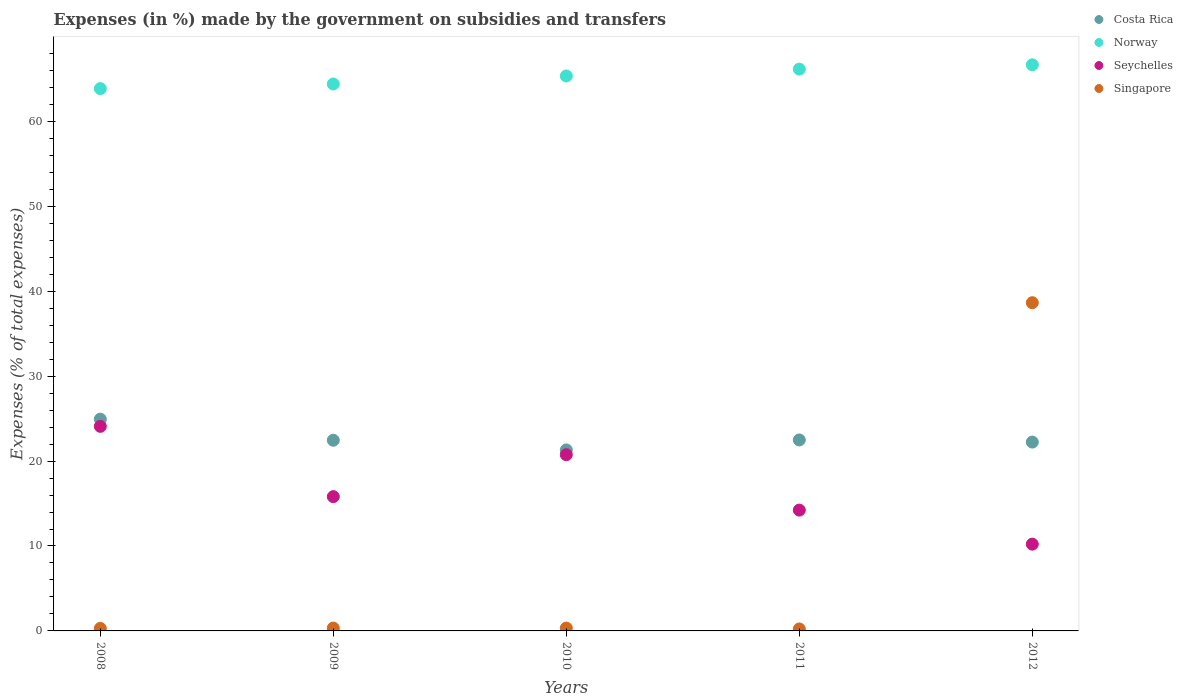Is the number of dotlines equal to the number of legend labels?
Offer a very short reply. Yes. What is the percentage of expenses made by the government on subsidies and transfers in Norway in 2010?
Your answer should be compact. 65.35. Across all years, what is the maximum percentage of expenses made by the government on subsidies and transfers in Singapore?
Provide a short and direct response. 38.65. Across all years, what is the minimum percentage of expenses made by the government on subsidies and transfers in Costa Rica?
Ensure brevity in your answer.  21.31. In which year was the percentage of expenses made by the government on subsidies and transfers in Singapore maximum?
Ensure brevity in your answer.  2012. What is the total percentage of expenses made by the government on subsidies and transfers in Costa Rica in the graph?
Offer a very short reply. 113.43. What is the difference between the percentage of expenses made by the government on subsidies and transfers in Seychelles in 2008 and that in 2010?
Provide a succinct answer. 3.34. What is the difference between the percentage of expenses made by the government on subsidies and transfers in Norway in 2011 and the percentage of expenses made by the government on subsidies and transfers in Costa Rica in 2008?
Provide a succinct answer. 41.22. What is the average percentage of expenses made by the government on subsidies and transfers in Seychelles per year?
Your answer should be very brief. 17.02. In the year 2008, what is the difference between the percentage of expenses made by the government on subsidies and transfers in Norway and percentage of expenses made by the government on subsidies and transfers in Singapore?
Make the answer very short. 63.56. In how many years, is the percentage of expenses made by the government on subsidies and transfers in Seychelles greater than 24 %?
Give a very brief answer. 1. What is the ratio of the percentage of expenses made by the government on subsidies and transfers in Seychelles in 2010 to that in 2012?
Give a very brief answer. 2.03. What is the difference between the highest and the second highest percentage of expenses made by the government on subsidies and transfers in Costa Rica?
Your response must be concise. 2.45. What is the difference between the highest and the lowest percentage of expenses made by the government on subsidies and transfers in Costa Rica?
Offer a terse response. 3.62. In how many years, is the percentage of expenses made by the government on subsidies and transfers in Norway greater than the average percentage of expenses made by the government on subsidies and transfers in Norway taken over all years?
Provide a succinct answer. 3. Is the sum of the percentage of expenses made by the government on subsidies and transfers in Norway in 2008 and 2011 greater than the maximum percentage of expenses made by the government on subsidies and transfers in Seychelles across all years?
Provide a succinct answer. Yes. Is it the case that in every year, the sum of the percentage of expenses made by the government on subsidies and transfers in Seychelles and percentage of expenses made by the government on subsidies and transfers in Norway  is greater than the sum of percentage of expenses made by the government on subsidies and transfers in Costa Rica and percentage of expenses made by the government on subsidies and transfers in Singapore?
Provide a succinct answer. Yes. Does the percentage of expenses made by the government on subsidies and transfers in Singapore monotonically increase over the years?
Keep it short and to the point. No. Is the percentage of expenses made by the government on subsidies and transfers in Costa Rica strictly less than the percentage of expenses made by the government on subsidies and transfers in Seychelles over the years?
Your answer should be very brief. No. How many dotlines are there?
Offer a very short reply. 4. Are the values on the major ticks of Y-axis written in scientific E-notation?
Your answer should be compact. No. Does the graph contain grids?
Give a very brief answer. No. How many legend labels are there?
Make the answer very short. 4. What is the title of the graph?
Your answer should be compact. Expenses (in %) made by the government on subsidies and transfers. Does "Russian Federation" appear as one of the legend labels in the graph?
Your answer should be compact. No. What is the label or title of the Y-axis?
Your answer should be compact. Expenses (% of total expenses). What is the Expenses (% of total expenses) in Costa Rica in 2008?
Keep it short and to the point. 24.94. What is the Expenses (% of total expenses) of Norway in 2008?
Provide a succinct answer. 63.86. What is the Expenses (% of total expenses) in Seychelles in 2008?
Offer a terse response. 24.09. What is the Expenses (% of total expenses) of Singapore in 2008?
Your answer should be compact. 0.3. What is the Expenses (% of total expenses) of Costa Rica in 2009?
Your answer should be compact. 22.45. What is the Expenses (% of total expenses) in Norway in 2009?
Ensure brevity in your answer.  64.4. What is the Expenses (% of total expenses) of Seychelles in 2009?
Your response must be concise. 15.81. What is the Expenses (% of total expenses) of Singapore in 2009?
Give a very brief answer. 0.34. What is the Expenses (% of total expenses) in Costa Rica in 2010?
Offer a terse response. 21.31. What is the Expenses (% of total expenses) in Norway in 2010?
Provide a succinct answer. 65.35. What is the Expenses (% of total expenses) in Seychelles in 2010?
Your response must be concise. 20.75. What is the Expenses (% of total expenses) in Singapore in 2010?
Your response must be concise. 0.33. What is the Expenses (% of total expenses) of Costa Rica in 2011?
Your answer should be very brief. 22.49. What is the Expenses (% of total expenses) in Norway in 2011?
Give a very brief answer. 66.15. What is the Expenses (% of total expenses) of Seychelles in 2011?
Your answer should be very brief. 14.23. What is the Expenses (% of total expenses) of Singapore in 2011?
Your answer should be very brief. 0.23. What is the Expenses (% of total expenses) in Costa Rica in 2012?
Offer a terse response. 22.24. What is the Expenses (% of total expenses) in Norway in 2012?
Ensure brevity in your answer.  66.66. What is the Expenses (% of total expenses) of Seychelles in 2012?
Give a very brief answer. 10.22. What is the Expenses (% of total expenses) in Singapore in 2012?
Give a very brief answer. 38.65. Across all years, what is the maximum Expenses (% of total expenses) in Costa Rica?
Your answer should be compact. 24.94. Across all years, what is the maximum Expenses (% of total expenses) of Norway?
Keep it short and to the point. 66.66. Across all years, what is the maximum Expenses (% of total expenses) of Seychelles?
Offer a terse response. 24.09. Across all years, what is the maximum Expenses (% of total expenses) in Singapore?
Offer a terse response. 38.65. Across all years, what is the minimum Expenses (% of total expenses) of Costa Rica?
Your answer should be very brief. 21.31. Across all years, what is the minimum Expenses (% of total expenses) in Norway?
Your answer should be very brief. 63.86. Across all years, what is the minimum Expenses (% of total expenses) in Seychelles?
Your answer should be compact. 10.22. Across all years, what is the minimum Expenses (% of total expenses) in Singapore?
Your answer should be very brief. 0.23. What is the total Expenses (% of total expenses) in Costa Rica in the graph?
Keep it short and to the point. 113.43. What is the total Expenses (% of total expenses) in Norway in the graph?
Keep it short and to the point. 326.43. What is the total Expenses (% of total expenses) of Seychelles in the graph?
Your answer should be compact. 85.1. What is the total Expenses (% of total expenses) of Singapore in the graph?
Your answer should be compact. 39.85. What is the difference between the Expenses (% of total expenses) of Costa Rica in 2008 and that in 2009?
Your response must be concise. 2.49. What is the difference between the Expenses (% of total expenses) in Norway in 2008 and that in 2009?
Ensure brevity in your answer.  -0.54. What is the difference between the Expenses (% of total expenses) of Seychelles in 2008 and that in 2009?
Offer a terse response. 8.27. What is the difference between the Expenses (% of total expenses) of Singapore in 2008 and that in 2009?
Keep it short and to the point. -0.04. What is the difference between the Expenses (% of total expenses) in Costa Rica in 2008 and that in 2010?
Provide a short and direct response. 3.62. What is the difference between the Expenses (% of total expenses) of Norway in 2008 and that in 2010?
Offer a terse response. -1.49. What is the difference between the Expenses (% of total expenses) in Seychelles in 2008 and that in 2010?
Your answer should be compact. 3.34. What is the difference between the Expenses (% of total expenses) of Singapore in 2008 and that in 2010?
Your answer should be compact. -0.03. What is the difference between the Expenses (% of total expenses) of Costa Rica in 2008 and that in 2011?
Ensure brevity in your answer.  2.45. What is the difference between the Expenses (% of total expenses) of Norway in 2008 and that in 2011?
Ensure brevity in your answer.  -2.3. What is the difference between the Expenses (% of total expenses) of Seychelles in 2008 and that in 2011?
Provide a short and direct response. 9.86. What is the difference between the Expenses (% of total expenses) of Singapore in 2008 and that in 2011?
Offer a very short reply. 0.07. What is the difference between the Expenses (% of total expenses) of Costa Rica in 2008 and that in 2012?
Your response must be concise. 2.7. What is the difference between the Expenses (% of total expenses) in Norway in 2008 and that in 2012?
Give a very brief answer. -2.81. What is the difference between the Expenses (% of total expenses) in Seychelles in 2008 and that in 2012?
Make the answer very short. 13.87. What is the difference between the Expenses (% of total expenses) in Singapore in 2008 and that in 2012?
Your answer should be compact. -38.35. What is the difference between the Expenses (% of total expenses) of Costa Rica in 2009 and that in 2010?
Give a very brief answer. 1.14. What is the difference between the Expenses (% of total expenses) of Norway in 2009 and that in 2010?
Ensure brevity in your answer.  -0.95. What is the difference between the Expenses (% of total expenses) in Seychelles in 2009 and that in 2010?
Keep it short and to the point. -4.93. What is the difference between the Expenses (% of total expenses) in Singapore in 2009 and that in 2010?
Give a very brief answer. 0. What is the difference between the Expenses (% of total expenses) in Costa Rica in 2009 and that in 2011?
Ensure brevity in your answer.  -0.04. What is the difference between the Expenses (% of total expenses) of Norway in 2009 and that in 2011?
Your answer should be compact. -1.75. What is the difference between the Expenses (% of total expenses) in Seychelles in 2009 and that in 2011?
Your response must be concise. 1.59. What is the difference between the Expenses (% of total expenses) of Singapore in 2009 and that in 2011?
Ensure brevity in your answer.  0.11. What is the difference between the Expenses (% of total expenses) of Costa Rica in 2009 and that in 2012?
Keep it short and to the point. 0.21. What is the difference between the Expenses (% of total expenses) in Norway in 2009 and that in 2012?
Give a very brief answer. -2.26. What is the difference between the Expenses (% of total expenses) of Seychelles in 2009 and that in 2012?
Provide a succinct answer. 5.6. What is the difference between the Expenses (% of total expenses) of Singapore in 2009 and that in 2012?
Provide a short and direct response. -38.31. What is the difference between the Expenses (% of total expenses) in Costa Rica in 2010 and that in 2011?
Keep it short and to the point. -1.17. What is the difference between the Expenses (% of total expenses) in Norway in 2010 and that in 2011?
Provide a short and direct response. -0.81. What is the difference between the Expenses (% of total expenses) of Seychelles in 2010 and that in 2011?
Keep it short and to the point. 6.52. What is the difference between the Expenses (% of total expenses) of Singapore in 2010 and that in 2011?
Provide a short and direct response. 0.1. What is the difference between the Expenses (% of total expenses) of Costa Rica in 2010 and that in 2012?
Your answer should be very brief. -0.92. What is the difference between the Expenses (% of total expenses) of Norway in 2010 and that in 2012?
Keep it short and to the point. -1.32. What is the difference between the Expenses (% of total expenses) in Seychelles in 2010 and that in 2012?
Ensure brevity in your answer.  10.53. What is the difference between the Expenses (% of total expenses) in Singapore in 2010 and that in 2012?
Provide a short and direct response. -38.31. What is the difference between the Expenses (% of total expenses) in Costa Rica in 2011 and that in 2012?
Provide a short and direct response. 0.25. What is the difference between the Expenses (% of total expenses) of Norway in 2011 and that in 2012?
Your response must be concise. -0.51. What is the difference between the Expenses (% of total expenses) of Seychelles in 2011 and that in 2012?
Offer a very short reply. 4.01. What is the difference between the Expenses (% of total expenses) in Singapore in 2011 and that in 2012?
Keep it short and to the point. -38.41. What is the difference between the Expenses (% of total expenses) in Costa Rica in 2008 and the Expenses (% of total expenses) in Norway in 2009?
Keep it short and to the point. -39.46. What is the difference between the Expenses (% of total expenses) in Costa Rica in 2008 and the Expenses (% of total expenses) in Seychelles in 2009?
Give a very brief answer. 9.12. What is the difference between the Expenses (% of total expenses) of Costa Rica in 2008 and the Expenses (% of total expenses) of Singapore in 2009?
Provide a short and direct response. 24.6. What is the difference between the Expenses (% of total expenses) of Norway in 2008 and the Expenses (% of total expenses) of Seychelles in 2009?
Your answer should be compact. 48.04. What is the difference between the Expenses (% of total expenses) of Norway in 2008 and the Expenses (% of total expenses) of Singapore in 2009?
Make the answer very short. 63.52. What is the difference between the Expenses (% of total expenses) in Seychelles in 2008 and the Expenses (% of total expenses) in Singapore in 2009?
Offer a terse response. 23.75. What is the difference between the Expenses (% of total expenses) of Costa Rica in 2008 and the Expenses (% of total expenses) of Norway in 2010?
Offer a terse response. -40.41. What is the difference between the Expenses (% of total expenses) of Costa Rica in 2008 and the Expenses (% of total expenses) of Seychelles in 2010?
Your answer should be compact. 4.19. What is the difference between the Expenses (% of total expenses) in Costa Rica in 2008 and the Expenses (% of total expenses) in Singapore in 2010?
Your answer should be very brief. 24.6. What is the difference between the Expenses (% of total expenses) in Norway in 2008 and the Expenses (% of total expenses) in Seychelles in 2010?
Provide a succinct answer. 43.11. What is the difference between the Expenses (% of total expenses) of Norway in 2008 and the Expenses (% of total expenses) of Singapore in 2010?
Your response must be concise. 63.52. What is the difference between the Expenses (% of total expenses) of Seychelles in 2008 and the Expenses (% of total expenses) of Singapore in 2010?
Your answer should be very brief. 23.75. What is the difference between the Expenses (% of total expenses) in Costa Rica in 2008 and the Expenses (% of total expenses) in Norway in 2011?
Give a very brief answer. -41.22. What is the difference between the Expenses (% of total expenses) of Costa Rica in 2008 and the Expenses (% of total expenses) of Seychelles in 2011?
Your answer should be compact. 10.71. What is the difference between the Expenses (% of total expenses) in Costa Rica in 2008 and the Expenses (% of total expenses) in Singapore in 2011?
Offer a very short reply. 24.7. What is the difference between the Expenses (% of total expenses) in Norway in 2008 and the Expenses (% of total expenses) in Seychelles in 2011?
Your answer should be compact. 49.63. What is the difference between the Expenses (% of total expenses) in Norway in 2008 and the Expenses (% of total expenses) in Singapore in 2011?
Offer a terse response. 63.62. What is the difference between the Expenses (% of total expenses) of Seychelles in 2008 and the Expenses (% of total expenses) of Singapore in 2011?
Your response must be concise. 23.86. What is the difference between the Expenses (% of total expenses) of Costa Rica in 2008 and the Expenses (% of total expenses) of Norway in 2012?
Make the answer very short. -41.73. What is the difference between the Expenses (% of total expenses) in Costa Rica in 2008 and the Expenses (% of total expenses) in Seychelles in 2012?
Give a very brief answer. 14.72. What is the difference between the Expenses (% of total expenses) of Costa Rica in 2008 and the Expenses (% of total expenses) of Singapore in 2012?
Your answer should be compact. -13.71. What is the difference between the Expenses (% of total expenses) in Norway in 2008 and the Expenses (% of total expenses) in Seychelles in 2012?
Make the answer very short. 53.64. What is the difference between the Expenses (% of total expenses) of Norway in 2008 and the Expenses (% of total expenses) of Singapore in 2012?
Your answer should be compact. 25.21. What is the difference between the Expenses (% of total expenses) of Seychelles in 2008 and the Expenses (% of total expenses) of Singapore in 2012?
Your answer should be compact. -14.56. What is the difference between the Expenses (% of total expenses) in Costa Rica in 2009 and the Expenses (% of total expenses) in Norway in 2010?
Your answer should be very brief. -42.9. What is the difference between the Expenses (% of total expenses) in Costa Rica in 2009 and the Expenses (% of total expenses) in Seychelles in 2010?
Ensure brevity in your answer.  1.7. What is the difference between the Expenses (% of total expenses) in Costa Rica in 2009 and the Expenses (% of total expenses) in Singapore in 2010?
Give a very brief answer. 22.12. What is the difference between the Expenses (% of total expenses) in Norway in 2009 and the Expenses (% of total expenses) in Seychelles in 2010?
Make the answer very short. 43.65. What is the difference between the Expenses (% of total expenses) in Norway in 2009 and the Expenses (% of total expenses) in Singapore in 2010?
Ensure brevity in your answer.  64.07. What is the difference between the Expenses (% of total expenses) in Seychelles in 2009 and the Expenses (% of total expenses) in Singapore in 2010?
Keep it short and to the point. 15.48. What is the difference between the Expenses (% of total expenses) in Costa Rica in 2009 and the Expenses (% of total expenses) in Norway in 2011?
Keep it short and to the point. -43.7. What is the difference between the Expenses (% of total expenses) in Costa Rica in 2009 and the Expenses (% of total expenses) in Seychelles in 2011?
Your answer should be very brief. 8.23. What is the difference between the Expenses (% of total expenses) in Costa Rica in 2009 and the Expenses (% of total expenses) in Singapore in 2011?
Offer a terse response. 22.22. What is the difference between the Expenses (% of total expenses) of Norway in 2009 and the Expenses (% of total expenses) of Seychelles in 2011?
Your response must be concise. 50.18. What is the difference between the Expenses (% of total expenses) in Norway in 2009 and the Expenses (% of total expenses) in Singapore in 2011?
Provide a short and direct response. 64.17. What is the difference between the Expenses (% of total expenses) in Seychelles in 2009 and the Expenses (% of total expenses) in Singapore in 2011?
Offer a terse response. 15.58. What is the difference between the Expenses (% of total expenses) in Costa Rica in 2009 and the Expenses (% of total expenses) in Norway in 2012?
Provide a succinct answer. -44.21. What is the difference between the Expenses (% of total expenses) of Costa Rica in 2009 and the Expenses (% of total expenses) of Seychelles in 2012?
Give a very brief answer. 12.23. What is the difference between the Expenses (% of total expenses) of Costa Rica in 2009 and the Expenses (% of total expenses) of Singapore in 2012?
Your answer should be compact. -16.2. What is the difference between the Expenses (% of total expenses) of Norway in 2009 and the Expenses (% of total expenses) of Seychelles in 2012?
Offer a terse response. 54.18. What is the difference between the Expenses (% of total expenses) in Norway in 2009 and the Expenses (% of total expenses) in Singapore in 2012?
Make the answer very short. 25.75. What is the difference between the Expenses (% of total expenses) in Seychelles in 2009 and the Expenses (% of total expenses) in Singapore in 2012?
Ensure brevity in your answer.  -22.83. What is the difference between the Expenses (% of total expenses) of Costa Rica in 2010 and the Expenses (% of total expenses) of Norway in 2011?
Give a very brief answer. -44.84. What is the difference between the Expenses (% of total expenses) in Costa Rica in 2010 and the Expenses (% of total expenses) in Seychelles in 2011?
Ensure brevity in your answer.  7.09. What is the difference between the Expenses (% of total expenses) of Costa Rica in 2010 and the Expenses (% of total expenses) of Singapore in 2011?
Give a very brief answer. 21.08. What is the difference between the Expenses (% of total expenses) in Norway in 2010 and the Expenses (% of total expenses) in Seychelles in 2011?
Ensure brevity in your answer.  51.12. What is the difference between the Expenses (% of total expenses) in Norway in 2010 and the Expenses (% of total expenses) in Singapore in 2011?
Keep it short and to the point. 65.11. What is the difference between the Expenses (% of total expenses) of Seychelles in 2010 and the Expenses (% of total expenses) of Singapore in 2011?
Ensure brevity in your answer.  20.51. What is the difference between the Expenses (% of total expenses) in Costa Rica in 2010 and the Expenses (% of total expenses) in Norway in 2012?
Provide a succinct answer. -45.35. What is the difference between the Expenses (% of total expenses) of Costa Rica in 2010 and the Expenses (% of total expenses) of Seychelles in 2012?
Make the answer very short. 11.1. What is the difference between the Expenses (% of total expenses) of Costa Rica in 2010 and the Expenses (% of total expenses) of Singapore in 2012?
Offer a terse response. -17.33. What is the difference between the Expenses (% of total expenses) of Norway in 2010 and the Expenses (% of total expenses) of Seychelles in 2012?
Your answer should be very brief. 55.13. What is the difference between the Expenses (% of total expenses) of Norway in 2010 and the Expenses (% of total expenses) of Singapore in 2012?
Your response must be concise. 26.7. What is the difference between the Expenses (% of total expenses) in Seychelles in 2010 and the Expenses (% of total expenses) in Singapore in 2012?
Give a very brief answer. -17.9. What is the difference between the Expenses (% of total expenses) of Costa Rica in 2011 and the Expenses (% of total expenses) of Norway in 2012?
Your answer should be very brief. -44.18. What is the difference between the Expenses (% of total expenses) of Costa Rica in 2011 and the Expenses (% of total expenses) of Seychelles in 2012?
Your answer should be compact. 12.27. What is the difference between the Expenses (% of total expenses) of Costa Rica in 2011 and the Expenses (% of total expenses) of Singapore in 2012?
Offer a very short reply. -16.16. What is the difference between the Expenses (% of total expenses) of Norway in 2011 and the Expenses (% of total expenses) of Seychelles in 2012?
Provide a succinct answer. 55.94. What is the difference between the Expenses (% of total expenses) in Norway in 2011 and the Expenses (% of total expenses) in Singapore in 2012?
Make the answer very short. 27.51. What is the difference between the Expenses (% of total expenses) in Seychelles in 2011 and the Expenses (% of total expenses) in Singapore in 2012?
Give a very brief answer. -24.42. What is the average Expenses (% of total expenses) of Costa Rica per year?
Keep it short and to the point. 22.69. What is the average Expenses (% of total expenses) of Norway per year?
Ensure brevity in your answer.  65.29. What is the average Expenses (% of total expenses) of Seychelles per year?
Your answer should be very brief. 17.02. What is the average Expenses (% of total expenses) in Singapore per year?
Make the answer very short. 7.97. In the year 2008, what is the difference between the Expenses (% of total expenses) of Costa Rica and Expenses (% of total expenses) of Norway?
Your response must be concise. -38.92. In the year 2008, what is the difference between the Expenses (% of total expenses) in Costa Rica and Expenses (% of total expenses) in Seychelles?
Offer a terse response. 0.85. In the year 2008, what is the difference between the Expenses (% of total expenses) in Costa Rica and Expenses (% of total expenses) in Singapore?
Your response must be concise. 24.64. In the year 2008, what is the difference between the Expenses (% of total expenses) in Norway and Expenses (% of total expenses) in Seychelles?
Your answer should be very brief. 39.77. In the year 2008, what is the difference between the Expenses (% of total expenses) in Norway and Expenses (% of total expenses) in Singapore?
Your answer should be very brief. 63.56. In the year 2008, what is the difference between the Expenses (% of total expenses) in Seychelles and Expenses (% of total expenses) in Singapore?
Provide a succinct answer. 23.79. In the year 2009, what is the difference between the Expenses (% of total expenses) in Costa Rica and Expenses (% of total expenses) in Norway?
Offer a terse response. -41.95. In the year 2009, what is the difference between the Expenses (% of total expenses) of Costa Rica and Expenses (% of total expenses) of Seychelles?
Provide a short and direct response. 6.64. In the year 2009, what is the difference between the Expenses (% of total expenses) in Costa Rica and Expenses (% of total expenses) in Singapore?
Ensure brevity in your answer.  22.11. In the year 2009, what is the difference between the Expenses (% of total expenses) of Norway and Expenses (% of total expenses) of Seychelles?
Make the answer very short. 48.59. In the year 2009, what is the difference between the Expenses (% of total expenses) in Norway and Expenses (% of total expenses) in Singapore?
Provide a short and direct response. 64.06. In the year 2009, what is the difference between the Expenses (% of total expenses) of Seychelles and Expenses (% of total expenses) of Singapore?
Your answer should be very brief. 15.48. In the year 2010, what is the difference between the Expenses (% of total expenses) of Costa Rica and Expenses (% of total expenses) of Norway?
Give a very brief answer. -44.03. In the year 2010, what is the difference between the Expenses (% of total expenses) of Costa Rica and Expenses (% of total expenses) of Seychelles?
Your response must be concise. 0.57. In the year 2010, what is the difference between the Expenses (% of total expenses) in Costa Rica and Expenses (% of total expenses) in Singapore?
Provide a succinct answer. 20.98. In the year 2010, what is the difference between the Expenses (% of total expenses) of Norway and Expenses (% of total expenses) of Seychelles?
Make the answer very short. 44.6. In the year 2010, what is the difference between the Expenses (% of total expenses) in Norway and Expenses (% of total expenses) in Singapore?
Provide a short and direct response. 65.01. In the year 2010, what is the difference between the Expenses (% of total expenses) of Seychelles and Expenses (% of total expenses) of Singapore?
Provide a short and direct response. 20.41. In the year 2011, what is the difference between the Expenses (% of total expenses) of Costa Rica and Expenses (% of total expenses) of Norway?
Provide a succinct answer. -43.67. In the year 2011, what is the difference between the Expenses (% of total expenses) of Costa Rica and Expenses (% of total expenses) of Seychelles?
Provide a succinct answer. 8.26. In the year 2011, what is the difference between the Expenses (% of total expenses) in Costa Rica and Expenses (% of total expenses) in Singapore?
Your response must be concise. 22.25. In the year 2011, what is the difference between the Expenses (% of total expenses) of Norway and Expenses (% of total expenses) of Seychelles?
Keep it short and to the point. 51.93. In the year 2011, what is the difference between the Expenses (% of total expenses) in Norway and Expenses (% of total expenses) in Singapore?
Give a very brief answer. 65.92. In the year 2011, what is the difference between the Expenses (% of total expenses) of Seychelles and Expenses (% of total expenses) of Singapore?
Your answer should be compact. 13.99. In the year 2012, what is the difference between the Expenses (% of total expenses) in Costa Rica and Expenses (% of total expenses) in Norway?
Your answer should be very brief. -44.43. In the year 2012, what is the difference between the Expenses (% of total expenses) of Costa Rica and Expenses (% of total expenses) of Seychelles?
Keep it short and to the point. 12.02. In the year 2012, what is the difference between the Expenses (% of total expenses) of Costa Rica and Expenses (% of total expenses) of Singapore?
Your answer should be very brief. -16.41. In the year 2012, what is the difference between the Expenses (% of total expenses) in Norway and Expenses (% of total expenses) in Seychelles?
Make the answer very short. 56.45. In the year 2012, what is the difference between the Expenses (% of total expenses) of Norway and Expenses (% of total expenses) of Singapore?
Your answer should be compact. 28.02. In the year 2012, what is the difference between the Expenses (% of total expenses) of Seychelles and Expenses (% of total expenses) of Singapore?
Your answer should be very brief. -28.43. What is the ratio of the Expenses (% of total expenses) of Costa Rica in 2008 to that in 2009?
Provide a short and direct response. 1.11. What is the ratio of the Expenses (% of total expenses) in Seychelles in 2008 to that in 2009?
Offer a terse response. 1.52. What is the ratio of the Expenses (% of total expenses) in Singapore in 2008 to that in 2009?
Offer a very short reply. 0.88. What is the ratio of the Expenses (% of total expenses) in Costa Rica in 2008 to that in 2010?
Your response must be concise. 1.17. What is the ratio of the Expenses (% of total expenses) in Norway in 2008 to that in 2010?
Offer a terse response. 0.98. What is the ratio of the Expenses (% of total expenses) of Seychelles in 2008 to that in 2010?
Keep it short and to the point. 1.16. What is the ratio of the Expenses (% of total expenses) of Singapore in 2008 to that in 2010?
Your answer should be compact. 0.9. What is the ratio of the Expenses (% of total expenses) of Costa Rica in 2008 to that in 2011?
Your answer should be compact. 1.11. What is the ratio of the Expenses (% of total expenses) in Norway in 2008 to that in 2011?
Provide a succinct answer. 0.97. What is the ratio of the Expenses (% of total expenses) of Seychelles in 2008 to that in 2011?
Your response must be concise. 1.69. What is the ratio of the Expenses (% of total expenses) of Singapore in 2008 to that in 2011?
Your response must be concise. 1.28. What is the ratio of the Expenses (% of total expenses) in Costa Rica in 2008 to that in 2012?
Ensure brevity in your answer.  1.12. What is the ratio of the Expenses (% of total expenses) in Norway in 2008 to that in 2012?
Your answer should be compact. 0.96. What is the ratio of the Expenses (% of total expenses) in Seychelles in 2008 to that in 2012?
Offer a very short reply. 2.36. What is the ratio of the Expenses (% of total expenses) in Singapore in 2008 to that in 2012?
Provide a short and direct response. 0.01. What is the ratio of the Expenses (% of total expenses) of Costa Rica in 2009 to that in 2010?
Provide a succinct answer. 1.05. What is the ratio of the Expenses (% of total expenses) in Norway in 2009 to that in 2010?
Give a very brief answer. 0.99. What is the ratio of the Expenses (% of total expenses) in Seychelles in 2009 to that in 2010?
Offer a very short reply. 0.76. What is the ratio of the Expenses (% of total expenses) in Singapore in 2009 to that in 2010?
Your answer should be very brief. 1.01. What is the ratio of the Expenses (% of total expenses) of Costa Rica in 2009 to that in 2011?
Offer a terse response. 1. What is the ratio of the Expenses (% of total expenses) of Norway in 2009 to that in 2011?
Provide a succinct answer. 0.97. What is the ratio of the Expenses (% of total expenses) in Seychelles in 2009 to that in 2011?
Ensure brevity in your answer.  1.11. What is the ratio of the Expenses (% of total expenses) in Singapore in 2009 to that in 2011?
Ensure brevity in your answer.  1.45. What is the ratio of the Expenses (% of total expenses) of Costa Rica in 2009 to that in 2012?
Your response must be concise. 1.01. What is the ratio of the Expenses (% of total expenses) in Norway in 2009 to that in 2012?
Your response must be concise. 0.97. What is the ratio of the Expenses (% of total expenses) of Seychelles in 2009 to that in 2012?
Provide a succinct answer. 1.55. What is the ratio of the Expenses (% of total expenses) of Singapore in 2009 to that in 2012?
Make the answer very short. 0.01. What is the ratio of the Expenses (% of total expenses) in Costa Rica in 2010 to that in 2011?
Give a very brief answer. 0.95. What is the ratio of the Expenses (% of total expenses) in Norway in 2010 to that in 2011?
Ensure brevity in your answer.  0.99. What is the ratio of the Expenses (% of total expenses) in Seychelles in 2010 to that in 2011?
Provide a succinct answer. 1.46. What is the ratio of the Expenses (% of total expenses) of Singapore in 2010 to that in 2011?
Provide a succinct answer. 1.43. What is the ratio of the Expenses (% of total expenses) in Costa Rica in 2010 to that in 2012?
Ensure brevity in your answer.  0.96. What is the ratio of the Expenses (% of total expenses) in Norway in 2010 to that in 2012?
Give a very brief answer. 0.98. What is the ratio of the Expenses (% of total expenses) in Seychelles in 2010 to that in 2012?
Ensure brevity in your answer.  2.03. What is the ratio of the Expenses (% of total expenses) in Singapore in 2010 to that in 2012?
Keep it short and to the point. 0.01. What is the ratio of the Expenses (% of total expenses) in Costa Rica in 2011 to that in 2012?
Make the answer very short. 1.01. What is the ratio of the Expenses (% of total expenses) in Seychelles in 2011 to that in 2012?
Offer a very short reply. 1.39. What is the ratio of the Expenses (% of total expenses) in Singapore in 2011 to that in 2012?
Give a very brief answer. 0.01. What is the difference between the highest and the second highest Expenses (% of total expenses) of Costa Rica?
Your response must be concise. 2.45. What is the difference between the highest and the second highest Expenses (% of total expenses) of Norway?
Offer a very short reply. 0.51. What is the difference between the highest and the second highest Expenses (% of total expenses) of Seychelles?
Provide a succinct answer. 3.34. What is the difference between the highest and the second highest Expenses (% of total expenses) in Singapore?
Make the answer very short. 38.31. What is the difference between the highest and the lowest Expenses (% of total expenses) of Costa Rica?
Your answer should be compact. 3.62. What is the difference between the highest and the lowest Expenses (% of total expenses) of Norway?
Your answer should be very brief. 2.81. What is the difference between the highest and the lowest Expenses (% of total expenses) of Seychelles?
Provide a succinct answer. 13.87. What is the difference between the highest and the lowest Expenses (% of total expenses) of Singapore?
Provide a short and direct response. 38.41. 